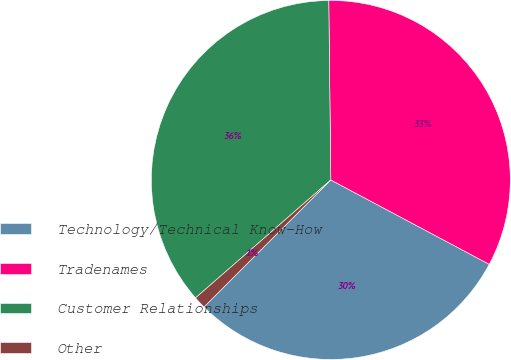<chart> <loc_0><loc_0><loc_500><loc_500><pie_chart><fcel>Technology/Technical Know-How<fcel>Tradenames<fcel>Customer Relationships<fcel>Other<nl><fcel>29.7%<fcel>32.97%<fcel>36.23%<fcel>1.1%<nl></chart> 